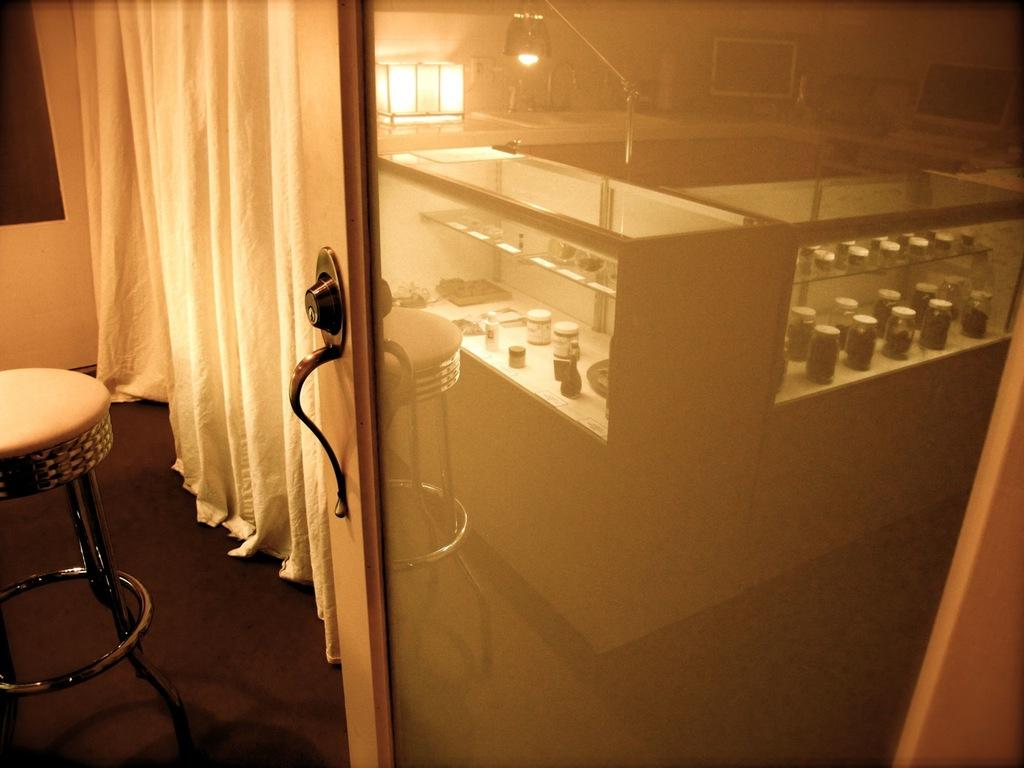What is on the floor in the image? There is a stool on the floor in the image. What can be seen hanging in the image? There is a curtain in the image. What is visible behind the curtain? There is a wall in the image. What is the purpose of the door in the image? The door in the image provides access to another room or area. What is the surface made of that the glass boxes, bottles, monitors, lights, and other objects are placed on? There is a glass surface in the image. What types of objects are placed on the glass surface? There are glass boxes, bottles, monitors, lights, and other objects on the glass surface. How many ducks are swimming in the glass boxes on the glass surface? There are no ducks present in the image, and the glass boxes do not contain water for ducks to swim in. What question is being asked by the objects on the glass surface? The objects on the glass surface are not capable of asking questions, as they are inanimate objects. 